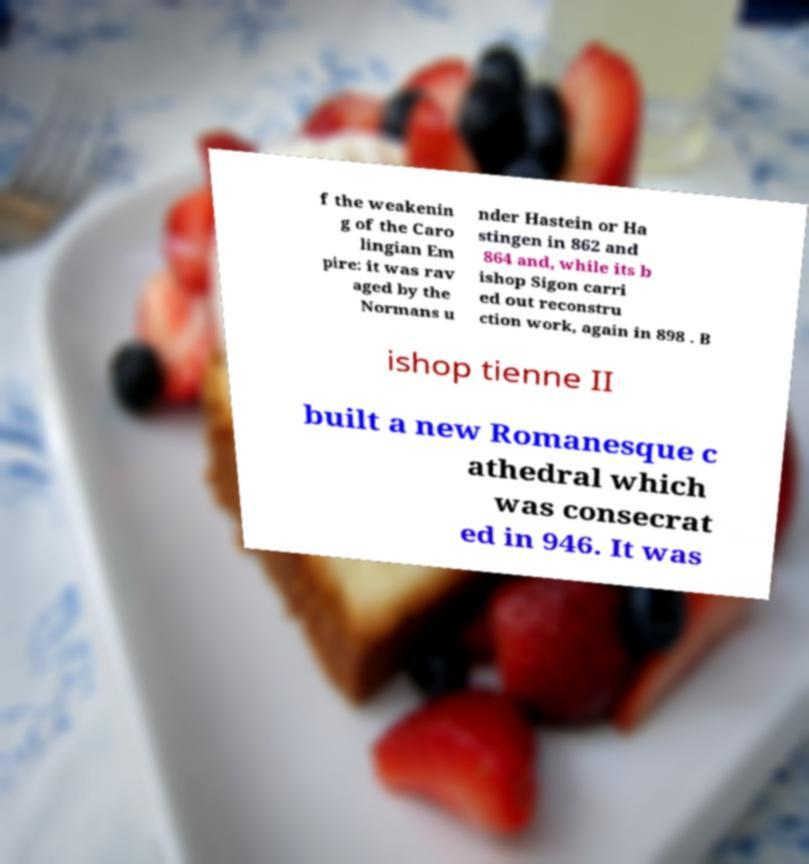What messages or text are displayed in this image? I need them in a readable, typed format. f the weakenin g of the Caro lingian Em pire: it was rav aged by the Normans u nder Hastein or Ha stingen in 862 and 864 and, while its b ishop Sigon carri ed out reconstru ction work, again in 898 . B ishop tienne II built a new Romanesque c athedral which was consecrat ed in 946. It was 